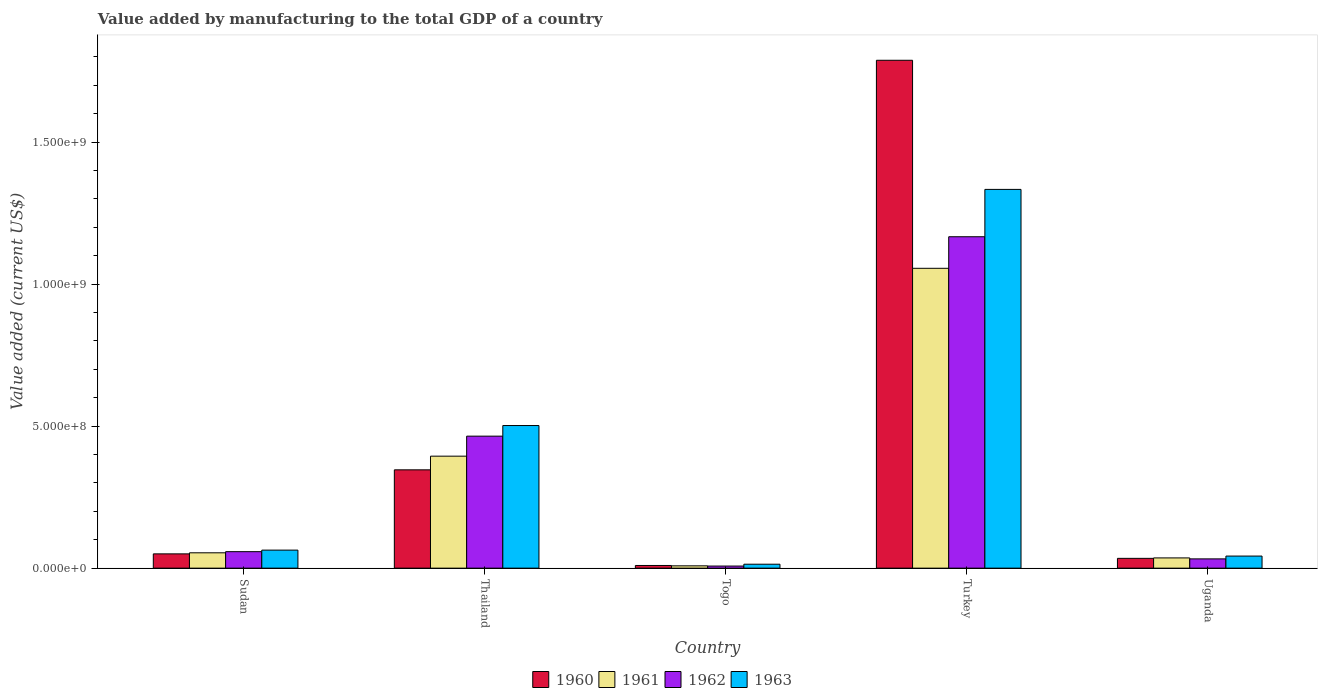How many different coloured bars are there?
Offer a terse response. 4. How many groups of bars are there?
Give a very brief answer. 5. What is the label of the 3rd group of bars from the left?
Your answer should be very brief. Togo. In how many cases, is the number of bars for a given country not equal to the number of legend labels?
Give a very brief answer. 0. What is the value added by manufacturing to the total GDP in 1960 in Turkey?
Your answer should be compact. 1.79e+09. Across all countries, what is the maximum value added by manufacturing to the total GDP in 1960?
Your response must be concise. 1.79e+09. Across all countries, what is the minimum value added by manufacturing to the total GDP in 1962?
Offer a terse response. 7.35e+06. In which country was the value added by manufacturing to the total GDP in 1960 maximum?
Keep it short and to the point. Turkey. In which country was the value added by manufacturing to the total GDP in 1962 minimum?
Make the answer very short. Togo. What is the total value added by manufacturing to the total GDP in 1961 in the graph?
Make the answer very short. 1.55e+09. What is the difference between the value added by manufacturing to the total GDP in 1961 in Thailand and that in Togo?
Offer a terse response. 3.86e+08. What is the difference between the value added by manufacturing to the total GDP in 1963 in Sudan and the value added by manufacturing to the total GDP in 1960 in Turkey?
Make the answer very short. -1.72e+09. What is the average value added by manufacturing to the total GDP in 1963 per country?
Make the answer very short. 3.91e+08. What is the difference between the value added by manufacturing to the total GDP of/in 1960 and value added by manufacturing to the total GDP of/in 1961 in Sudan?
Offer a terse response. -3.73e+06. In how many countries, is the value added by manufacturing to the total GDP in 1962 greater than 1100000000 US$?
Make the answer very short. 1. What is the ratio of the value added by manufacturing to the total GDP in 1963 in Sudan to that in Uganda?
Offer a terse response. 1.49. What is the difference between the highest and the second highest value added by manufacturing to the total GDP in 1961?
Your response must be concise. -6.61e+08. What is the difference between the highest and the lowest value added by manufacturing to the total GDP in 1960?
Your answer should be compact. 1.78e+09. In how many countries, is the value added by manufacturing to the total GDP in 1962 greater than the average value added by manufacturing to the total GDP in 1962 taken over all countries?
Ensure brevity in your answer.  2. Is the sum of the value added by manufacturing to the total GDP in 1960 in Thailand and Togo greater than the maximum value added by manufacturing to the total GDP in 1963 across all countries?
Provide a short and direct response. No. Is it the case that in every country, the sum of the value added by manufacturing to the total GDP in 1961 and value added by manufacturing to the total GDP in 1960 is greater than the sum of value added by manufacturing to the total GDP in 1962 and value added by manufacturing to the total GDP in 1963?
Provide a succinct answer. No. What does the 4th bar from the right in Sudan represents?
Your answer should be compact. 1960. Is it the case that in every country, the sum of the value added by manufacturing to the total GDP in 1960 and value added by manufacturing to the total GDP in 1961 is greater than the value added by manufacturing to the total GDP in 1963?
Keep it short and to the point. Yes. How many bars are there?
Provide a short and direct response. 20. Are the values on the major ticks of Y-axis written in scientific E-notation?
Your answer should be compact. Yes. Does the graph contain any zero values?
Your answer should be very brief. No. Does the graph contain grids?
Provide a short and direct response. No. Where does the legend appear in the graph?
Offer a terse response. Bottom center. How many legend labels are there?
Provide a succinct answer. 4. What is the title of the graph?
Offer a terse response. Value added by manufacturing to the total GDP of a country. What is the label or title of the X-axis?
Your answer should be very brief. Country. What is the label or title of the Y-axis?
Ensure brevity in your answer.  Value added (current US$). What is the Value added (current US$) of 1960 in Sudan?
Make the answer very short. 5.03e+07. What is the Value added (current US$) in 1961 in Sudan?
Keep it short and to the point. 5.40e+07. What is the Value added (current US$) of 1962 in Sudan?
Make the answer very short. 5.80e+07. What is the Value added (current US$) of 1963 in Sudan?
Offer a terse response. 6.35e+07. What is the Value added (current US$) in 1960 in Thailand?
Your response must be concise. 3.46e+08. What is the Value added (current US$) of 1961 in Thailand?
Provide a succinct answer. 3.94e+08. What is the Value added (current US$) in 1962 in Thailand?
Provide a succinct answer. 4.65e+08. What is the Value added (current US$) of 1963 in Thailand?
Give a very brief answer. 5.02e+08. What is the Value added (current US$) of 1960 in Togo?
Keep it short and to the point. 9.38e+06. What is the Value added (current US$) in 1961 in Togo?
Your response must be concise. 8.15e+06. What is the Value added (current US$) of 1962 in Togo?
Provide a short and direct response. 7.35e+06. What is the Value added (current US$) in 1963 in Togo?
Your response must be concise. 1.39e+07. What is the Value added (current US$) of 1960 in Turkey?
Your answer should be compact. 1.79e+09. What is the Value added (current US$) in 1961 in Turkey?
Your answer should be very brief. 1.06e+09. What is the Value added (current US$) in 1962 in Turkey?
Your answer should be very brief. 1.17e+09. What is the Value added (current US$) of 1963 in Turkey?
Offer a terse response. 1.33e+09. What is the Value added (current US$) of 1960 in Uganda?
Your answer should be very brief. 3.45e+07. What is the Value added (current US$) of 1961 in Uganda?
Give a very brief answer. 3.60e+07. What is the Value added (current US$) of 1962 in Uganda?
Give a very brief answer. 3.26e+07. What is the Value added (current US$) of 1963 in Uganda?
Provide a short and direct response. 4.25e+07. Across all countries, what is the maximum Value added (current US$) in 1960?
Ensure brevity in your answer.  1.79e+09. Across all countries, what is the maximum Value added (current US$) in 1961?
Offer a very short reply. 1.06e+09. Across all countries, what is the maximum Value added (current US$) of 1962?
Your answer should be very brief. 1.17e+09. Across all countries, what is the maximum Value added (current US$) of 1963?
Offer a very short reply. 1.33e+09. Across all countries, what is the minimum Value added (current US$) in 1960?
Provide a short and direct response. 9.38e+06. Across all countries, what is the minimum Value added (current US$) in 1961?
Offer a very short reply. 8.15e+06. Across all countries, what is the minimum Value added (current US$) in 1962?
Offer a very short reply. 7.35e+06. Across all countries, what is the minimum Value added (current US$) in 1963?
Your answer should be very brief. 1.39e+07. What is the total Value added (current US$) of 1960 in the graph?
Give a very brief answer. 2.23e+09. What is the total Value added (current US$) of 1961 in the graph?
Make the answer very short. 1.55e+09. What is the total Value added (current US$) in 1962 in the graph?
Your answer should be compact. 1.73e+09. What is the total Value added (current US$) in 1963 in the graph?
Ensure brevity in your answer.  1.96e+09. What is the difference between the Value added (current US$) of 1960 in Sudan and that in Thailand?
Keep it short and to the point. -2.96e+08. What is the difference between the Value added (current US$) in 1961 in Sudan and that in Thailand?
Provide a short and direct response. -3.40e+08. What is the difference between the Value added (current US$) in 1962 in Sudan and that in Thailand?
Give a very brief answer. -4.07e+08. What is the difference between the Value added (current US$) of 1963 in Sudan and that in Thailand?
Make the answer very short. -4.39e+08. What is the difference between the Value added (current US$) of 1960 in Sudan and that in Togo?
Provide a succinct answer. 4.09e+07. What is the difference between the Value added (current US$) in 1961 in Sudan and that in Togo?
Offer a terse response. 4.58e+07. What is the difference between the Value added (current US$) in 1962 in Sudan and that in Togo?
Your answer should be compact. 5.07e+07. What is the difference between the Value added (current US$) of 1963 in Sudan and that in Togo?
Provide a succinct answer. 4.96e+07. What is the difference between the Value added (current US$) of 1960 in Sudan and that in Turkey?
Your answer should be compact. -1.74e+09. What is the difference between the Value added (current US$) of 1961 in Sudan and that in Turkey?
Offer a terse response. -1.00e+09. What is the difference between the Value added (current US$) in 1962 in Sudan and that in Turkey?
Your response must be concise. -1.11e+09. What is the difference between the Value added (current US$) in 1963 in Sudan and that in Turkey?
Your answer should be compact. -1.27e+09. What is the difference between the Value added (current US$) of 1960 in Sudan and that in Uganda?
Make the answer very short. 1.58e+07. What is the difference between the Value added (current US$) in 1961 in Sudan and that in Uganda?
Ensure brevity in your answer.  1.80e+07. What is the difference between the Value added (current US$) in 1962 in Sudan and that in Uganda?
Provide a short and direct response. 2.54e+07. What is the difference between the Value added (current US$) of 1963 in Sudan and that in Uganda?
Give a very brief answer. 2.10e+07. What is the difference between the Value added (current US$) of 1960 in Thailand and that in Togo?
Keep it short and to the point. 3.37e+08. What is the difference between the Value added (current US$) of 1961 in Thailand and that in Togo?
Provide a short and direct response. 3.86e+08. What is the difference between the Value added (current US$) in 1962 in Thailand and that in Togo?
Ensure brevity in your answer.  4.57e+08. What is the difference between the Value added (current US$) in 1963 in Thailand and that in Togo?
Provide a short and direct response. 4.88e+08. What is the difference between the Value added (current US$) of 1960 in Thailand and that in Turkey?
Your answer should be compact. -1.44e+09. What is the difference between the Value added (current US$) of 1961 in Thailand and that in Turkey?
Provide a short and direct response. -6.61e+08. What is the difference between the Value added (current US$) in 1962 in Thailand and that in Turkey?
Keep it short and to the point. -7.02e+08. What is the difference between the Value added (current US$) in 1963 in Thailand and that in Turkey?
Your answer should be compact. -8.31e+08. What is the difference between the Value added (current US$) in 1960 in Thailand and that in Uganda?
Your answer should be very brief. 3.12e+08. What is the difference between the Value added (current US$) in 1961 in Thailand and that in Uganda?
Offer a very short reply. 3.58e+08. What is the difference between the Value added (current US$) in 1962 in Thailand and that in Uganda?
Make the answer very short. 4.32e+08. What is the difference between the Value added (current US$) of 1963 in Thailand and that in Uganda?
Your answer should be very brief. 4.60e+08. What is the difference between the Value added (current US$) of 1960 in Togo and that in Turkey?
Give a very brief answer. -1.78e+09. What is the difference between the Value added (current US$) of 1961 in Togo and that in Turkey?
Provide a short and direct response. -1.05e+09. What is the difference between the Value added (current US$) in 1962 in Togo and that in Turkey?
Keep it short and to the point. -1.16e+09. What is the difference between the Value added (current US$) in 1963 in Togo and that in Turkey?
Offer a terse response. -1.32e+09. What is the difference between the Value added (current US$) of 1960 in Togo and that in Uganda?
Provide a short and direct response. -2.51e+07. What is the difference between the Value added (current US$) in 1961 in Togo and that in Uganda?
Provide a succinct answer. -2.79e+07. What is the difference between the Value added (current US$) in 1962 in Togo and that in Uganda?
Your answer should be compact. -2.53e+07. What is the difference between the Value added (current US$) of 1963 in Togo and that in Uganda?
Offer a terse response. -2.86e+07. What is the difference between the Value added (current US$) in 1960 in Turkey and that in Uganda?
Keep it short and to the point. 1.75e+09. What is the difference between the Value added (current US$) in 1961 in Turkey and that in Uganda?
Give a very brief answer. 1.02e+09. What is the difference between the Value added (current US$) in 1962 in Turkey and that in Uganda?
Provide a short and direct response. 1.13e+09. What is the difference between the Value added (current US$) in 1963 in Turkey and that in Uganda?
Make the answer very short. 1.29e+09. What is the difference between the Value added (current US$) of 1960 in Sudan and the Value added (current US$) of 1961 in Thailand?
Your answer should be very brief. -3.44e+08. What is the difference between the Value added (current US$) of 1960 in Sudan and the Value added (current US$) of 1962 in Thailand?
Provide a short and direct response. -4.14e+08. What is the difference between the Value added (current US$) in 1960 in Sudan and the Value added (current US$) in 1963 in Thailand?
Your answer should be compact. -4.52e+08. What is the difference between the Value added (current US$) of 1961 in Sudan and the Value added (current US$) of 1962 in Thailand?
Your answer should be very brief. -4.11e+08. What is the difference between the Value added (current US$) in 1961 in Sudan and the Value added (current US$) in 1963 in Thailand?
Keep it short and to the point. -4.48e+08. What is the difference between the Value added (current US$) in 1962 in Sudan and the Value added (current US$) in 1963 in Thailand?
Your answer should be very brief. -4.44e+08. What is the difference between the Value added (current US$) of 1960 in Sudan and the Value added (current US$) of 1961 in Togo?
Make the answer very short. 4.21e+07. What is the difference between the Value added (current US$) of 1960 in Sudan and the Value added (current US$) of 1962 in Togo?
Make the answer very short. 4.29e+07. What is the difference between the Value added (current US$) in 1960 in Sudan and the Value added (current US$) in 1963 in Togo?
Provide a short and direct response. 3.64e+07. What is the difference between the Value added (current US$) of 1961 in Sudan and the Value added (current US$) of 1962 in Togo?
Make the answer very short. 4.66e+07. What is the difference between the Value added (current US$) in 1961 in Sudan and the Value added (current US$) in 1963 in Togo?
Give a very brief answer. 4.01e+07. What is the difference between the Value added (current US$) in 1962 in Sudan and the Value added (current US$) in 1963 in Togo?
Provide a short and direct response. 4.41e+07. What is the difference between the Value added (current US$) in 1960 in Sudan and the Value added (current US$) in 1961 in Turkey?
Offer a terse response. -1.01e+09. What is the difference between the Value added (current US$) in 1960 in Sudan and the Value added (current US$) in 1962 in Turkey?
Your response must be concise. -1.12e+09. What is the difference between the Value added (current US$) in 1960 in Sudan and the Value added (current US$) in 1963 in Turkey?
Ensure brevity in your answer.  -1.28e+09. What is the difference between the Value added (current US$) in 1961 in Sudan and the Value added (current US$) in 1962 in Turkey?
Your answer should be compact. -1.11e+09. What is the difference between the Value added (current US$) in 1961 in Sudan and the Value added (current US$) in 1963 in Turkey?
Keep it short and to the point. -1.28e+09. What is the difference between the Value added (current US$) of 1962 in Sudan and the Value added (current US$) of 1963 in Turkey?
Give a very brief answer. -1.28e+09. What is the difference between the Value added (current US$) in 1960 in Sudan and the Value added (current US$) in 1961 in Uganda?
Give a very brief answer. 1.42e+07. What is the difference between the Value added (current US$) in 1960 in Sudan and the Value added (current US$) in 1962 in Uganda?
Your answer should be compact. 1.76e+07. What is the difference between the Value added (current US$) in 1960 in Sudan and the Value added (current US$) in 1963 in Uganda?
Your response must be concise. 7.75e+06. What is the difference between the Value added (current US$) of 1961 in Sudan and the Value added (current US$) of 1962 in Uganda?
Ensure brevity in your answer.  2.14e+07. What is the difference between the Value added (current US$) in 1961 in Sudan and the Value added (current US$) in 1963 in Uganda?
Provide a succinct answer. 1.15e+07. What is the difference between the Value added (current US$) in 1962 in Sudan and the Value added (current US$) in 1963 in Uganda?
Offer a terse response. 1.55e+07. What is the difference between the Value added (current US$) of 1960 in Thailand and the Value added (current US$) of 1961 in Togo?
Offer a terse response. 3.38e+08. What is the difference between the Value added (current US$) in 1960 in Thailand and the Value added (current US$) in 1962 in Togo?
Give a very brief answer. 3.39e+08. What is the difference between the Value added (current US$) of 1960 in Thailand and the Value added (current US$) of 1963 in Togo?
Make the answer very short. 3.32e+08. What is the difference between the Value added (current US$) of 1961 in Thailand and the Value added (current US$) of 1962 in Togo?
Your answer should be very brief. 3.87e+08. What is the difference between the Value added (current US$) of 1961 in Thailand and the Value added (current US$) of 1963 in Togo?
Your answer should be very brief. 3.80e+08. What is the difference between the Value added (current US$) in 1962 in Thailand and the Value added (current US$) in 1963 in Togo?
Provide a succinct answer. 4.51e+08. What is the difference between the Value added (current US$) in 1960 in Thailand and the Value added (current US$) in 1961 in Turkey?
Your response must be concise. -7.09e+08. What is the difference between the Value added (current US$) of 1960 in Thailand and the Value added (current US$) of 1962 in Turkey?
Provide a succinct answer. -8.21e+08. What is the difference between the Value added (current US$) of 1960 in Thailand and the Value added (current US$) of 1963 in Turkey?
Your response must be concise. -9.87e+08. What is the difference between the Value added (current US$) of 1961 in Thailand and the Value added (current US$) of 1962 in Turkey?
Your answer should be very brief. -7.72e+08. What is the difference between the Value added (current US$) of 1961 in Thailand and the Value added (current US$) of 1963 in Turkey?
Your answer should be very brief. -9.39e+08. What is the difference between the Value added (current US$) of 1962 in Thailand and the Value added (current US$) of 1963 in Turkey?
Give a very brief answer. -8.69e+08. What is the difference between the Value added (current US$) in 1960 in Thailand and the Value added (current US$) in 1961 in Uganda?
Make the answer very short. 3.10e+08. What is the difference between the Value added (current US$) of 1960 in Thailand and the Value added (current US$) of 1962 in Uganda?
Make the answer very short. 3.13e+08. What is the difference between the Value added (current US$) of 1960 in Thailand and the Value added (current US$) of 1963 in Uganda?
Keep it short and to the point. 3.04e+08. What is the difference between the Value added (current US$) in 1961 in Thailand and the Value added (current US$) in 1962 in Uganda?
Make the answer very short. 3.62e+08. What is the difference between the Value added (current US$) of 1961 in Thailand and the Value added (current US$) of 1963 in Uganda?
Ensure brevity in your answer.  3.52e+08. What is the difference between the Value added (current US$) of 1962 in Thailand and the Value added (current US$) of 1963 in Uganda?
Offer a very short reply. 4.22e+08. What is the difference between the Value added (current US$) in 1960 in Togo and the Value added (current US$) in 1961 in Turkey?
Ensure brevity in your answer.  -1.05e+09. What is the difference between the Value added (current US$) of 1960 in Togo and the Value added (current US$) of 1962 in Turkey?
Make the answer very short. -1.16e+09. What is the difference between the Value added (current US$) in 1960 in Togo and the Value added (current US$) in 1963 in Turkey?
Provide a short and direct response. -1.32e+09. What is the difference between the Value added (current US$) of 1961 in Togo and the Value added (current US$) of 1962 in Turkey?
Your answer should be very brief. -1.16e+09. What is the difference between the Value added (current US$) in 1961 in Togo and the Value added (current US$) in 1963 in Turkey?
Your answer should be compact. -1.33e+09. What is the difference between the Value added (current US$) in 1962 in Togo and the Value added (current US$) in 1963 in Turkey?
Offer a very short reply. -1.33e+09. What is the difference between the Value added (current US$) in 1960 in Togo and the Value added (current US$) in 1961 in Uganda?
Ensure brevity in your answer.  -2.66e+07. What is the difference between the Value added (current US$) in 1960 in Togo and the Value added (current US$) in 1962 in Uganda?
Offer a terse response. -2.33e+07. What is the difference between the Value added (current US$) in 1960 in Togo and the Value added (current US$) in 1963 in Uganda?
Your answer should be compact. -3.31e+07. What is the difference between the Value added (current US$) of 1961 in Togo and the Value added (current US$) of 1962 in Uganda?
Make the answer very short. -2.45e+07. What is the difference between the Value added (current US$) in 1961 in Togo and the Value added (current US$) in 1963 in Uganda?
Your response must be concise. -3.44e+07. What is the difference between the Value added (current US$) of 1962 in Togo and the Value added (current US$) of 1963 in Uganda?
Keep it short and to the point. -3.52e+07. What is the difference between the Value added (current US$) of 1960 in Turkey and the Value added (current US$) of 1961 in Uganda?
Provide a succinct answer. 1.75e+09. What is the difference between the Value added (current US$) of 1960 in Turkey and the Value added (current US$) of 1962 in Uganda?
Your answer should be very brief. 1.76e+09. What is the difference between the Value added (current US$) in 1960 in Turkey and the Value added (current US$) in 1963 in Uganda?
Offer a terse response. 1.75e+09. What is the difference between the Value added (current US$) in 1961 in Turkey and the Value added (current US$) in 1962 in Uganda?
Keep it short and to the point. 1.02e+09. What is the difference between the Value added (current US$) in 1961 in Turkey and the Value added (current US$) in 1963 in Uganda?
Keep it short and to the point. 1.01e+09. What is the difference between the Value added (current US$) of 1962 in Turkey and the Value added (current US$) of 1963 in Uganda?
Offer a very short reply. 1.12e+09. What is the average Value added (current US$) of 1960 per country?
Offer a terse response. 4.46e+08. What is the average Value added (current US$) of 1961 per country?
Your answer should be very brief. 3.10e+08. What is the average Value added (current US$) in 1962 per country?
Provide a short and direct response. 3.46e+08. What is the average Value added (current US$) of 1963 per country?
Ensure brevity in your answer.  3.91e+08. What is the difference between the Value added (current US$) in 1960 and Value added (current US$) in 1961 in Sudan?
Make the answer very short. -3.73e+06. What is the difference between the Value added (current US$) of 1960 and Value added (current US$) of 1962 in Sudan?
Ensure brevity in your answer.  -7.75e+06. What is the difference between the Value added (current US$) of 1960 and Value added (current US$) of 1963 in Sudan?
Give a very brief answer. -1.32e+07. What is the difference between the Value added (current US$) of 1961 and Value added (current US$) of 1962 in Sudan?
Your answer should be compact. -4.02e+06. What is the difference between the Value added (current US$) in 1961 and Value added (current US$) in 1963 in Sudan?
Keep it short and to the point. -9.48e+06. What is the difference between the Value added (current US$) in 1962 and Value added (current US$) in 1963 in Sudan?
Keep it short and to the point. -5.46e+06. What is the difference between the Value added (current US$) in 1960 and Value added (current US$) in 1961 in Thailand?
Give a very brief answer. -4.81e+07. What is the difference between the Value added (current US$) in 1960 and Value added (current US$) in 1962 in Thailand?
Make the answer very short. -1.19e+08. What is the difference between the Value added (current US$) in 1960 and Value added (current US$) in 1963 in Thailand?
Ensure brevity in your answer.  -1.56e+08. What is the difference between the Value added (current US$) in 1961 and Value added (current US$) in 1962 in Thailand?
Offer a terse response. -7.05e+07. What is the difference between the Value added (current US$) in 1961 and Value added (current US$) in 1963 in Thailand?
Provide a short and direct response. -1.08e+08. What is the difference between the Value added (current US$) of 1962 and Value added (current US$) of 1963 in Thailand?
Provide a short and direct response. -3.73e+07. What is the difference between the Value added (current US$) of 1960 and Value added (current US$) of 1961 in Togo?
Your answer should be very brief. 1.23e+06. What is the difference between the Value added (current US$) of 1960 and Value added (current US$) of 1962 in Togo?
Offer a very short reply. 2.03e+06. What is the difference between the Value added (current US$) of 1960 and Value added (current US$) of 1963 in Togo?
Keep it short and to the point. -4.50e+06. What is the difference between the Value added (current US$) in 1961 and Value added (current US$) in 1962 in Togo?
Your answer should be compact. 8.08e+05. What is the difference between the Value added (current US$) of 1961 and Value added (current US$) of 1963 in Togo?
Keep it short and to the point. -5.72e+06. What is the difference between the Value added (current US$) of 1962 and Value added (current US$) of 1963 in Togo?
Give a very brief answer. -6.53e+06. What is the difference between the Value added (current US$) in 1960 and Value added (current US$) in 1961 in Turkey?
Provide a succinct answer. 7.32e+08. What is the difference between the Value added (current US$) of 1960 and Value added (current US$) of 1962 in Turkey?
Offer a terse response. 6.21e+08. What is the difference between the Value added (current US$) in 1960 and Value added (current US$) in 1963 in Turkey?
Your response must be concise. 4.55e+08. What is the difference between the Value added (current US$) of 1961 and Value added (current US$) of 1962 in Turkey?
Give a very brief answer. -1.11e+08. What is the difference between the Value added (current US$) in 1961 and Value added (current US$) in 1963 in Turkey?
Keep it short and to the point. -2.78e+08. What is the difference between the Value added (current US$) in 1962 and Value added (current US$) in 1963 in Turkey?
Your answer should be very brief. -1.67e+08. What is the difference between the Value added (current US$) in 1960 and Value added (current US$) in 1961 in Uganda?
Your answer should be very brief. -1.54e+06. What is the difference between the Value added (current US$) in 1960 and Value added (current US$) in 1962 in Uganda?
Your answer should be very brief. 1.85e+06. What is the difference between the Value added (current US$) in 1960 and Value added (current US$) in 1963 in Uganda?
Provide a succinct answer. -8.03e+06. What is the difference between the Value added (current US$) in 1961 and Value added (current US$) in 1962 in Uganda?
Provide a short and direct response. 3.39e+06. What is the difference between the Value added (current US$) in 1961 and Value added (current US$) in 1963 in Uganda?
Provide a succinct answer. -6.48e+06. What is the difference between the Value added (current US$) of 1962 and Value added (current US$) of 1963 in Uganda?
Provide a short and direct response. -9.87e+06. What is the ratio of the Value added (current US$) in 1960 in Sudan to that in Thailand?
Ensure brevity in your answer.  0.15. What is the ratio of the Value added (current US$) in 1961 in Sudan to that in Thailand?
Your response must be concise. 0.14. What is the ratio of the Value added (current US$) of 1962 in Sudan to that in Thailand?
Provide a succinct answer. 0.12. What is the ratio of the Value added (current US$) in 1963 in Sudan to that in Thailand?
Your response must be concise. 0.13. What is the ratio of the Value added (current US$) in 1960 in Sudan to that in Togo?
Keep it short and to the point. 5.36. What is the ratio of the Value added (current US$) of 1961 in Sudan to that in Togo?
Provide a short and direct response. 6.62. What is the ratio of the Value added (current US$) of 1962 in Sudan to that in Togo?
Ensure brevity in your answer.  7.9. What is the ratio of the Value added (current US$) of 1963 in Sudan to that in Togo?
Provide a short and direct response. 4.57. What is the ratio of the Value added (current US$) in 1960 in Sudan to that in Turkey?
Make the answer very short. 0.03. What is the ratio of the Value added (current US$) in 1961 in Sudan to that in Turkey?
Provide a short and direct response. 0.05. What is the ratio of the Value added (current US$) in 1962 in Sudan to that in Turkey?
Provide a succinct answer. 0.05. What is the ratio of the Value added (current US$) of 1963 in Sudan to that in Turkey?
Provide a short and direct response. 0.05. What is the ratio of the Value added (current US$) in 1960 in Sudan to that in Uganda?
Offer a terse response. 1.46. What is the ratio of the Value added (current US$) of 1961 in Sudan to that in Uganda?
Offer a very short reply. 1.5. What is the ratio of the Value added (current US$) in 1962 in Sudan to that in Uganda?
Ensure brevity in your answer.  1.78. What is the ratio of the Value added (current US$) of 1963 in Sudan to that in Uganda?
Your answer should be compact. 1.49. What is the ratio of the Value added (current US$) of 1960 in Thailand to that in Togo?
Offer a very short reply. 36.9. What is the ratio of the Value added (current US$) of 1961 in Thailand to that in Togo?
Give a very brief answer. 48.34. What is the ratio of the Value added (current US$) of 1962 in Thailand to that in Togo?
Ensure brevity in your answer.  63.26. What is the ratio of the Value added (current US$) in 1963 in Thailand to that in Togo?
Provide a short and direct response. 36.18. What is the ratio of the Value added (current US$) in 1960 in Thailand to that in Turkey?
Offer a very short reply. 0.19. What is the ratio of the Value added (current US$) of 1961 in Thailand to that in Turkey?
Provide a short and direct response. 0.37. What is the ratio of the Value added (current US$) of 1962 in Thailand to that in Turkey?
Offer a very short reply. 0.4. What is the ratio of the Value added (current US$) in 1963 in Thailand to that in Turkey?
Your answer should be compact. 0.38. What is the ratio of the Value added (current US$) in 1960 in Thailand to that in Uganda?
Your answer should be compact. 10.04. What is the ratio of the Value added (current US$) of 1961 in Thailand to that in Uganda?
Provide a succinct answer. 10.94. What is the ratio of the Value added (current US$) in 1962 in Thailand to that in Uganda?
Give a very brief answer. 14.24. What is the ratio of the Value added (current US$) in 1963 in Thailand to that in Uganda?
Provide a short and direct response. 11.81. What is the ratio of the Value added (current US$) in 1960 in Togo to that in Turkey?
Your answer should be compact. 0.01. What is the ratio of the Value added (current US$) of 1961 in Togo to that in Turkey?
Your response must be concise. 0.01. What is the ratio of the Value added (current US$) of 1962 in Togo to that in Turkey?
Provide a short and direct response. 0.01. What is the ratio of the Value added (current US$) in 1963 in Togo to that in Turkey?
Your response must be concise. 0.01. What is the ratio of the Value added (current US$) in 1960 in Togo to that in Uganda?
Keep it short and to the point. 0.27. What is the ratio of the Value added (current US$) in 1961 in Togo to that in Uganda?
Your response must be concise. 0.23. What is the ratio of the Value added (current US$) of 1962 in Togo to that in Uganda?
Ensure brevity in your answer.  0.23. What is the ratio of the Value added (current US$) of 1963 in Togo to that in Uganda?
Ensure brevity in your answer.  0.33. What is the ratio of the Value added (current US$) of 1960 in Turkey to that in Uganda?
Give a very brief answer. 51.86. What is the ratio of the Value added (current US$) of 1961 in Turkey to that in Uganda?
Make the answer very short. 29.3. What is the ratio of the Value added (current US$) of 1962 in Turkey to that in Uganda?
Keep it short and to the point. 35.75. What is the ratio of the Value added (current US$) in 1963 in Turkey to that in Uganda?
Offer a terse response. 31.37. What is the difference between the highest and the second highest Value added (current US$) in 1960?
Keep it short and to the point. 1.44e+09. What is the difference between the highest and the second highest Value added (current US$) in 1961?
Your answer should be compact. 6.61e+08. What is the difference between the highest and the second highest Value added (current US$) of 1962?
Provide a succinct answer. 7.02e+08. What is the difference between the highest and the second highest Value added (current US$) of 1963?
Keep it short and to the point. 8.31e+08. What is the difference between the highest and the lowest Value added (current US$) of 1960?
Your answer should be very brief. 1.78e+09. What is the difference between the highest and the lowest Value added (current US$) in 1961?
Provide a succinct answer. 1.05e+09. What is the difference between the highest and the lowest Value added (current US$) in 1962?
Your answer should be compact. 1.16e+09. What is the difference between the highest and the lowest Value added (current US$) of 1963?
Make the answer very short. 1.32e+09. 